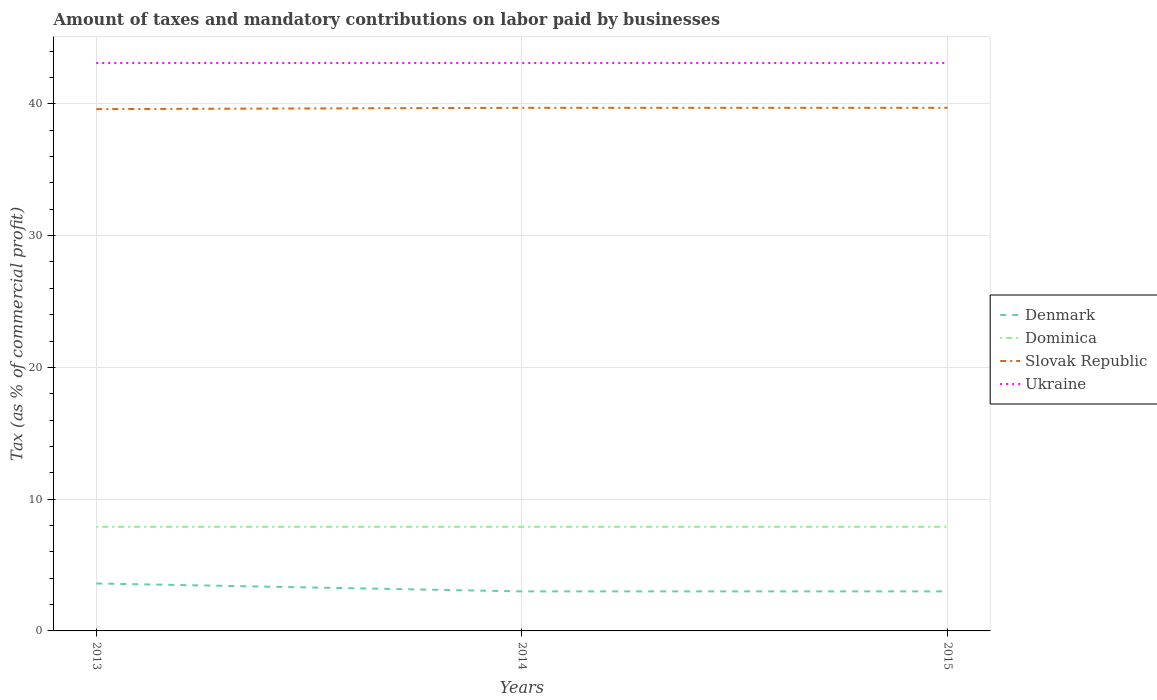How many different coloured lines are there?
Give a very brief answer. 4. Is the number of lines equal to the number of legend labels?
Offer a very short reply. Yes. Across all years, what is the maximum percentage of taxes paid by businesses in Ukraine?
Your answer should be very brief. 43.1. What is the total percentage of taxes paid by businesses in Dominica in the graph?
Keep it short and to the point. 0. What is the difference between the highest and the second highest percentage of taxes paid by businesses in Slovak Republic?
Keep it short and to the point. 0.1. What is the difference between the highest and the lowest percentage of taxes paid by businesses in Ukraine?
Keep it short and to the point. 0. How many years are there in the graph?
Provide a short and direct response. 3. What is the difference between two consecutive major ticks on the Y-axis?
Your answer should be very brief. 10. Are the values on the major ticks of Y-axis written in scientific E-notation?
Give a very brief answer. No. Where does the legend appear in the graph?
Provide a short and direct response. Center right. How are the legend labels stacked?
Your response must be concise. Vertical. What is the title of the graph?
Provide a succinct answer. Amount of taxes and mandatory contributions on labor paid by businesses. Does "Portugal" appear as one of the legend labels in the graph?
Ensure brevity in your answer.  No. What is the label or title of the Y-axis?
Offer a very short reply. Tax (as % of commercial profit). What is the Tax (as % of commercial profit) of Denmark in 2013?
Make the answer very short. 3.6. What is the Tax (as % of commercial profit) in Dominica in 2013?
Your answer should be very brief. 7.9. What is the Tax (as % of commercial profit) in Slovak Republic in 2013?
Keep it short and to the point. 39.6. What is the Tax (as % of commercial profit) in Ukraine in 2013?
Make the answer very short. 43.1. What is the Tax (as % of commercial profit) of Slovak Republic in 2014?
Your response must be concise. 39.7. What is the Tax (as % of commercial profit) of Ukraine in 2014?
Ensure brevity in your answer.  43.1. What is the Tax (as % of commercial profit) in Denmark in 2015?
Provide a succinct answer. 3. What is the Tax (as % of commercial profit) of Slovak Republic in 2015?
Provide a short and direct response. 39.7. What is the Tax (as % of commercial profit) of Ukraine in 2015?
Keep it short and to the point. 43.1. Across all years, what is the maximum Tax (as % of commercial profit) of Slovak Republic?
Provide a short and direct response. 39.7. Across all years, what is the maximum Tax (as % of commercial profit) in Ukraine?
Ensure brevity in your answer.  43.1. Across all years, what is the minimum Tax (as % of commercial profit) in Slovak Republic?
Make the answer very short. 39.6. Across all years, what is the minimum Tax (as % of commercial profit) in Ukraine?
Your response must be concise. 43.1. What is the total Tax (as % of commercial profit) of Denmark in the graph?
Your answer should be compact. 9.6. What is the total Tax (as % of commercial profit) of Dominica in the graph?
Provide a short and direct response. 23.7. What is the total Tax (as % of commercial profit) of Slovak Republic in the graph?
Provide a succinct answer. 119. What is the total Tax (as % of commercial profit) in Ukraine in the graph?
Provide a succinct answer. 129.3. What is the difference between the Tax (as % of commercial profit) in Denmark in 2013 and that in 2014?
Keep it short and to the point. 0.6. What is the difference between the Tax (as % of commercial profit) in Slovak Republic in 2013 and that in 2014?
Give a very brief answer. -0.1. What is the difference between the Tax (as % of commercial profit) in Denmark in 2014 and that in 2015?
Your answer should be compact. 0. What is the difference between the Tax (as % of commercial profit) of Slovak Republic in 2014 and that in 2015?
Make the answer very short. 0. What is the difference between the Tax (as % of commercial profit) in Ukraine in 2014 and that in 2015?
Provide a succinct answer. 0. What is the difference between the Tax (as % of commercial profit) in Denmark in 2013 and the Tax (as % of commercial profit) in Dominica in 2014?
Your answer should be very brief. -4.3. What is the difference between the Tax (as % of commercial profit) in Denmark in 2013 and the Tax (as % of commercial profit) in Slovak Republic in 2014?
Make the answer very short. -36.1. What is the difference between the Tax (as % of commercial profit) of Denmark in 2013 and the Tax (as % of commercial profit) of Ukraine in 2014?
Make the answer very short. -39.5. What is the difference between the Tax (as % of commercial profit) of Dominica in 2013 and the Tax (as % of commercial profit) of Slovak Republic in 2014?
Offer a terse response. -31.8. What is the difference between the Tax (as % of commercial profit) in Dominica in 2013 and the Tax (as % of commercial profit) in Ukraine in 2014?
Make the answer very short. -35.2. What is the difference between the Tax (as % of commercial profit) in Slovak Republic in 2013 and the Tax (as % of commercial profit) in Ukraine in 2014?
Provide a short and direct response. -3.5. What is the difference between the Tax (as % of commercial profit) of Denmark in 2013 and the Tax (as % of commercial profit) of Slovak Republic in 2015?
Keep it short and to the point. -36.1. What is the difference between the Tax (as % of commercial profit) of Denmark in 2013 and the Tax (as % of commercial profit) of Ukraine in 2015?
Keep it short and to the point. -39.5. What is the difference between the Tax (as % of commercial profit) of Dominica in 2013 and the Tax (as % of commercial profit) of Slovak Republic in 2015?
Ensure brevity in your answer.  -31.8. What is the difference between the Tax (as % of commercial profit) in Dominica in 2013 and the Tax (as % of commercial profit) in Ukraine in 2015?
Offer a very short reply. -35.2. What is the difference between the Tax (as % of commercial profit) in Slovak Republic in 2013 and the Tax (as % of commercial profit) in Ukraine in 2015?
Give a very brief answer. -3.5. What is the difference between the Tax (as % of commercial profit) of Denmark in 2014 and the Tax (as % of commercial profit) of Slovak Republic in 2015?
Your answer should be compact. -36.7. What is the difference between the Tax (as % of commercial profit) of Denmark in 2014 and the Tax (as % of commercial profit) of Ukraine in 2015?
Give a very brief answer. -40.1. What is the difference between the Tax (as % of commercial profit) in Dominica in 2014 and the Tax (as % of commercial profit) in Slovak Republic in 2015?
Your answer should be very brief. -31.8. What is the difference between the Tax (as % of commercial profit) in Dominica in 2014 and the Tax (as % of commercial profit) in Ukraine in 2015?
Make the answer very short. -35.2. What is the difference between the Tax (as % of commercial profit) in Slovak Republic in 2014 and the Tax (as % of commercial profit) in Ukraine in 2015?
Your answer should be very brief. -3.4. What is the average Tax (as % of commercial profit) in Denmark per year?
Your response must be concise. 3.2. What is the average Tax (as % of commercial profit) in Slovak Republic per year?
Provide a short and direct response. 39.67. What is the average Tax (as % of commercial profit) of Ukraine per year?
Your response must be concise. 43.1. In the year 2013, what is the difference between the Tax (as % of commercial profit) in Denmark and Tax (as % of commercial profit) in Slovak Republic?
Make the answer very short. -36. In the year 2013, what is the difference between the Tax (as % of commercial profit) in Denmark and Tax (as % of commercial profit) in Ukraine?
Offer a very short reply. -39.5. In the year 2013, what is the difference between the Tax (as % of commercial profit) of Dominica and Tax (as % of commercial profit) of Slovak Republic?
Your answer should be compact. -31.7. In the year 2013, what is the difference between the Tax (as % of commercial profit) in Dominica and Tax (as % of commercial profit) in Ukraine?
Provide a short and direct response. -35.2. In the year 2014, what is the difference between the Tax (as % of commercial profit) in Denmark and Tax (as % of commercial profit) in Dominica?
Offer a very short reply. -4.9. In the year 2014, what is the difference between the Tax (as % of commercial profit) in Denmark and Tax (as % of commercial profit) in Slovak Republic?
Offer a very short reply. -36.7. In the year 2014, what is the difference between the Tax (as % of commercial profit) in Denmark and Tax (as % of commercial profit) in Ukraine?
Offer a very short reply. -40.1. In the year 2014, what is the difference between the Tax (as % of commercial profit) in Dominica and Tax (as % of commercial profit) in Slovak Republic?
Your response must be concise. -31.8. In the year 2014, what is the difference between the Tax (as % of commercial profit) in Dominica and Tax (as % of commercial profit) in Ukraine?
Offer a very short reply. -35.2. In the year 2014, what is the difference between the Tax (as % of commercial profit) in Slovak Republic and Tax (as % of commercial profit) in Ukraine?
Your answer should be very brief. -3.4. In the year 2015, what is the difference between the Tax (as % of commercial profit) of Denmark and Tax (as % of commercial profit) of Slovak Republic?
Make the answer very short. -36.7. In the year 2015, what is the difference between the Tax (as % of commercial profit) in Denmark and Tax (as % of commercial profit) in Ukraine?
Offer a terse response. -40.1. In the year 2015, what is the difference between the Tax (as % of commercial profit) in Dominica and Tax (as % of commercial profit) in Slovak Republic?
Keep it short and to the point. -31.8. In the year 2015, what is the difference between the Tax (as % of commercial profit) in Dominica and Tax (as % of commercial profit) in Ukraine?
Give a very brief answer. -35.2. What is the ratio of the Tax (as % of commercial profit) in Dominica in 2013 to that in 2014?
Ensure brevity in your answer.  1. What is the ratio of the Tax (as % of commercial profit) in Slovak Republic in 2013 to that in 2014?
Offer a terse response. 1. What is the ratio of the Tax (as % of commercial profit) of Ukraine in 2013 to that in 2014?
Provide a short and direct response. 1. What is the ratio of the Tax (as % of commercial profit) in Dominica in 2013 to that in 2015?
Your answer should be very brief. 1. What is the ratio of the Tax (as % of commercial profit) of Slovak Republic in 2013 to that in 2015?
Provide a succinct answer. 1. What is the ratio of the Tax (as % of commercial profit) in Denmark in 2014 to that in 2015?
Ensure brevity in your answer.  1. What is the ratio of the Tax (as % of commercial profit) in Slovak Republic in 2014 to that in 2015?
Your answer should be compact. 1. What is the ratio of the Tax (as % of commercial profit) of Ukraine in 2014 to that in 2015?
Offer a terse response. 1. What is the difference between the highest and the second highest Tax (as % of commercial profit) of Denmark?
Provide a succinct answer. 0.6. What is the difference between the highest and the second highest Tax (as % of commercial profit) of Ukraine?
Make the answer very short. 0. What is the difference between the highest and the lowest Tax (as % of commercial profit) in Denmark?
Your response must be concise. 0.6. What is the difference between the highest and the lowest Tax (as % of commercial profit) of Dominica?
Provide a short and direct response. 0. What is the difference between the highest and the lowest Tax (as % of commercial profit) in Ukraine?
Provide a short and direct response. 0. 